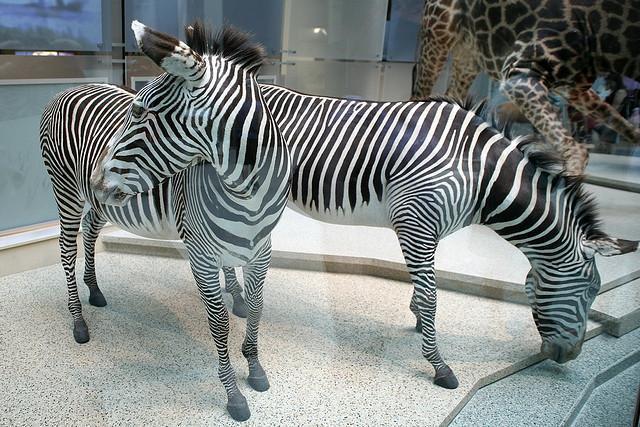How many zebras are in the picture?
Give a very brief answer. 2. How many cows are visible?
Give a very brief answer. 0. 